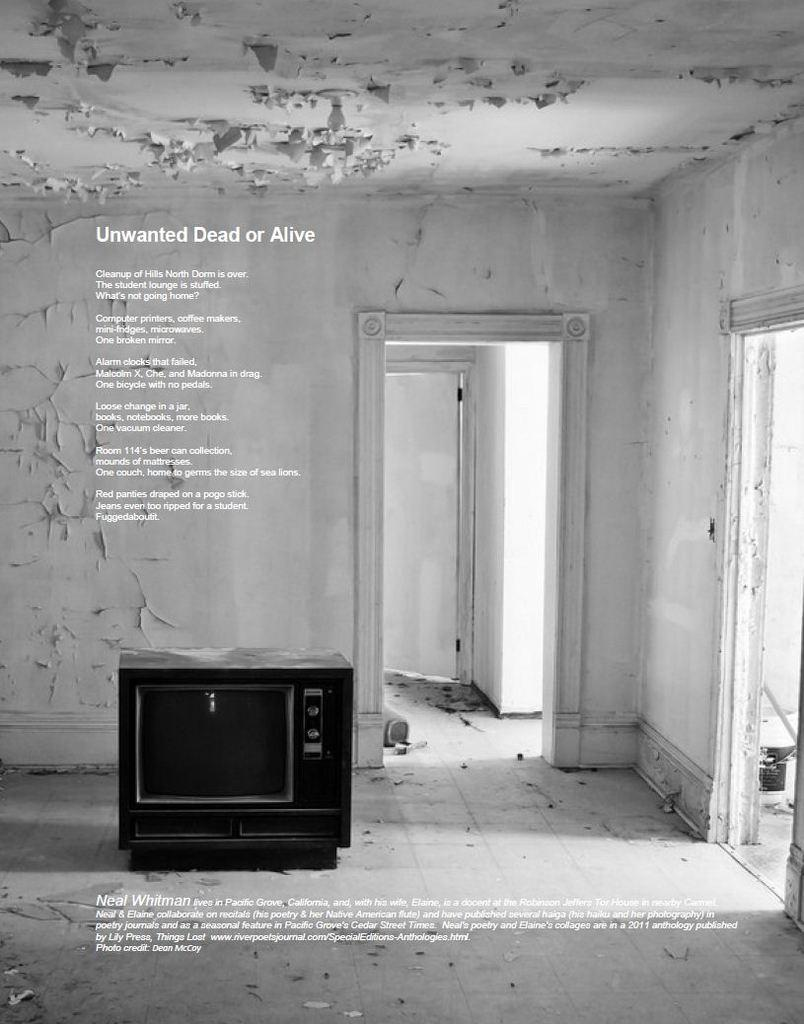<image>
Write a terse but informative summary of the picture. Ad or page of a magazine that is titled, "Unwanted Dead or Alive". 